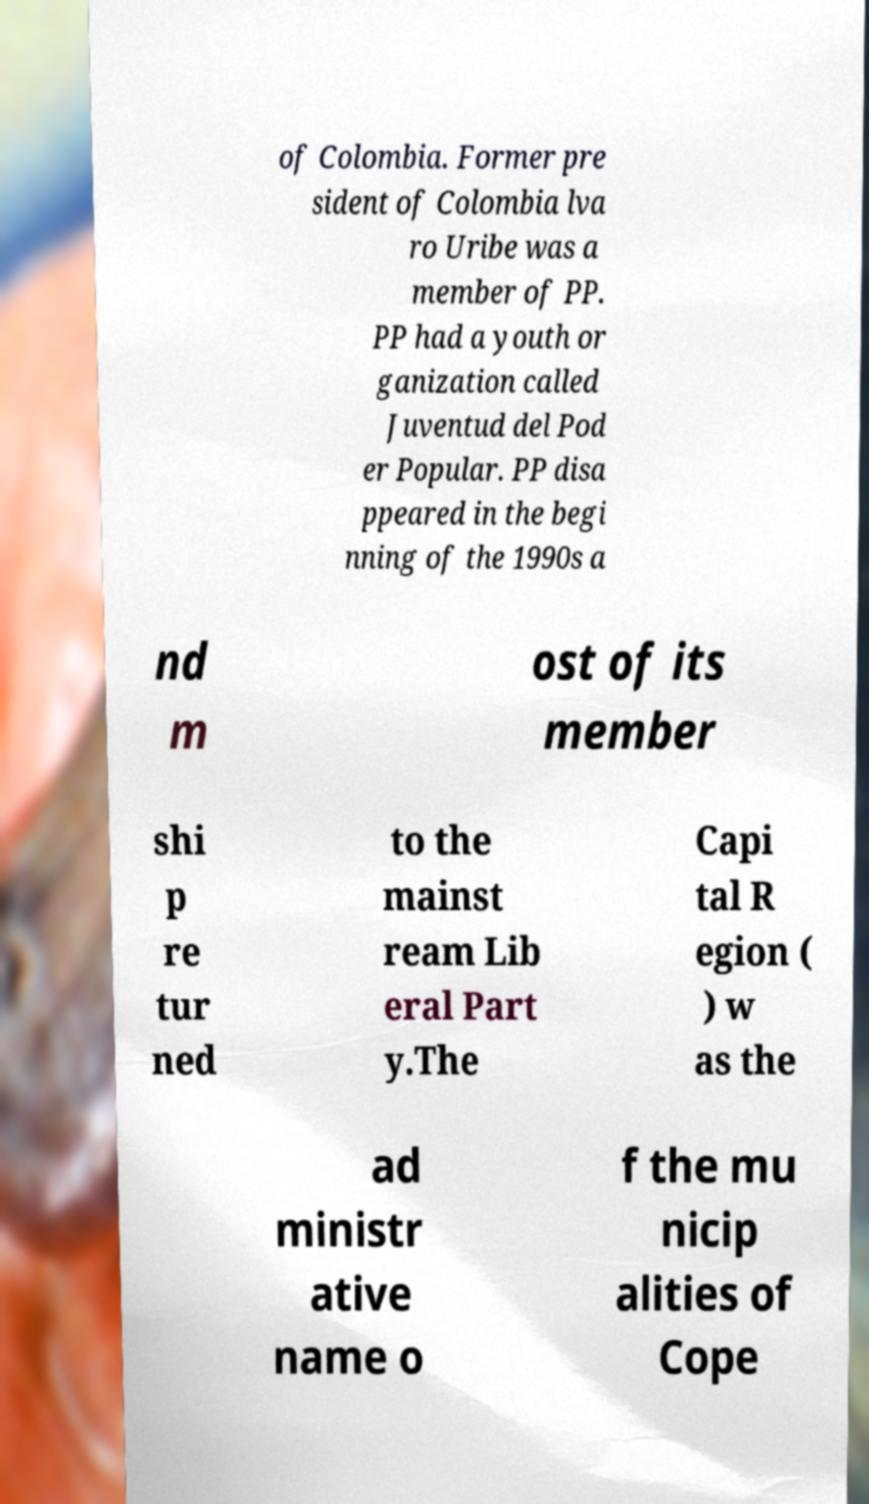There's text embedded in this image that I need extracted. Can you transcribe it verbatim? of Colombia. Former pre sident of Colombia lva ro Uribe was a member of PP. PP had a youth or ganization called Juventud del Pod er Popular. PP disa ppeared in the begi nning of the 1990s a nd m ost of its member shi p re tur ned to the mainst ream Lib eral Part y.The Capi tal R egion ( ) w as the ad ministr ative name o f the mu nicip alities of Cope 